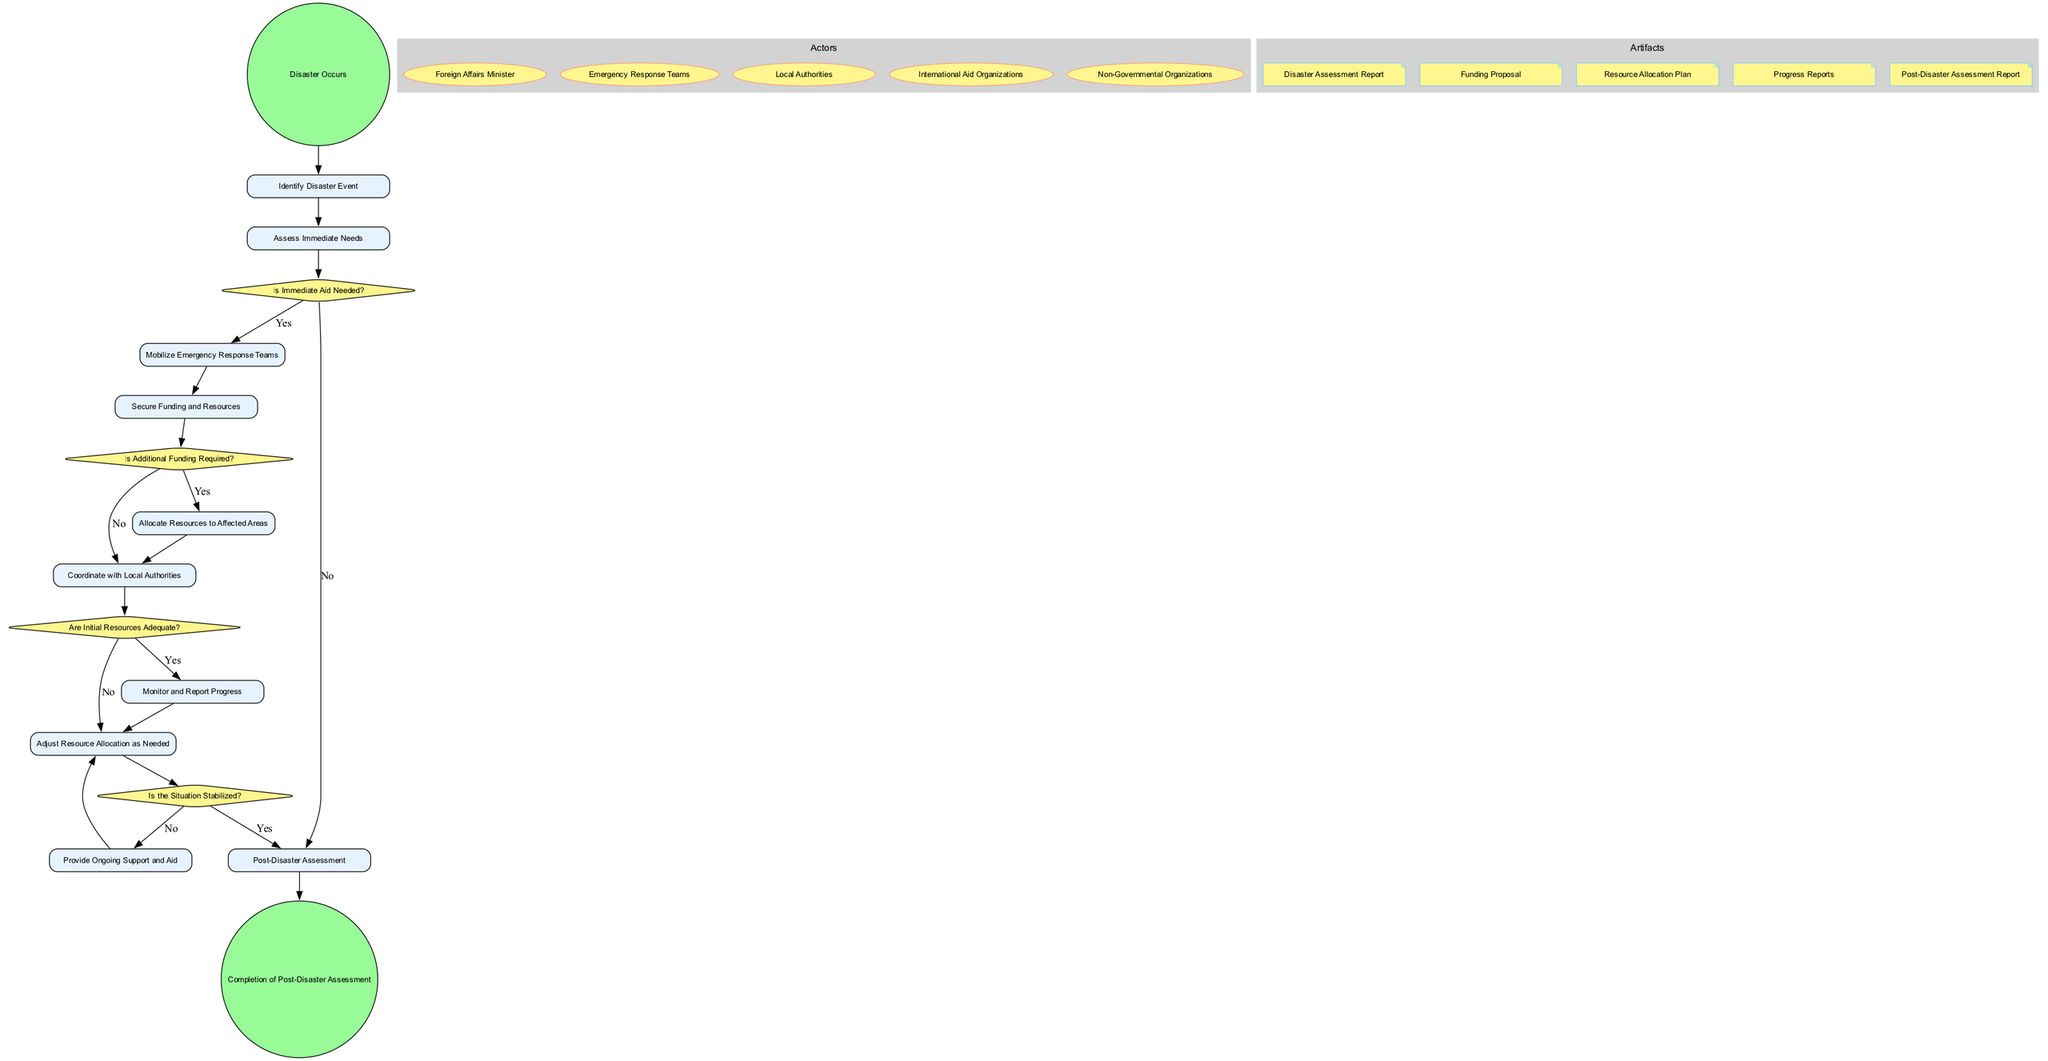What is the first activity in the diagram? The diagram starts with the event labeled "Disaster Occurs," and the first activity that follows it is labeled "Identify Disaster Event."
Answer: Identify Disaster Event How many decisions are in the diagram? There are four decisions listed in the diagram: "Is Immediate Aid Needed?", "Is Additional Funding Required?", "Are Initial Resources Adequate?", and "Is the Situation Stabilized?" Counting these gives a total of four.
Answer: 4 What happens after assessing immediate needs if immediate aid is needed? If immediate aid is needed, the flow proceeds from "Assess Immediate Needs" to "Mobilize Emergency Response Teams" based on the decision from "Is Immediate Aid Needed?" labeled 'Yes.'
Answer: Mobilize Emergency Response Teams Which activity follows the allocation of resources to affected areas? Following the activity "Allocate Resources to Affected Areas," the next activity in the flow of the diagram is "Coordinate with Local Authorities."
Answer: Coordinate with Local Authorities How does the diagram conclude? The diagram ultimately concludes with the event labeled "Completion of Post-Disaster Assessment," indicating that the process has reached its end after all activities have been carried out.
Answer: Completion of Post-Disaster Assessment What are the actors involved in the process? The actors involved are listed as: "Foreign Affairs Minister," "Emergency Response Teams," "Local Authorities," "International Aid Organizations," and "Non-Governmental Organizations."
Answer: Foreign Affairs Minister, Emergency Response Teams, Local Authorities, International Aid Organizations, Non-Governmental Organizations What decision is made after initially assessing resources? After assessing immediate needs and mobilizing emergency response teams, the next decision made is "Is Additional Funding Required?" to determine if further funding is needed.
Answer: Is Additional Funding Required? What document is created after assessing the disaster? The first artifact generated after identifying the disaster is the "Disaster Assessment Report," which is crucial for the subsequent allocations of resources and funding proposals.
Answer: Disaster Assessment Report 